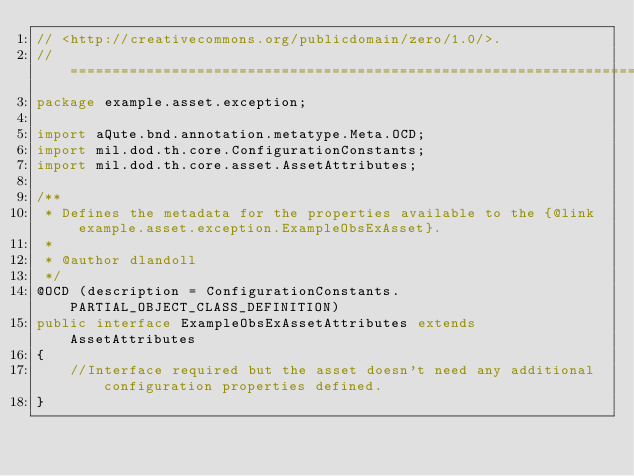<code> <loc_0><loc_0><loc_500><loc_500><_Java_>// <http://creativecommons.org/publicdomain/zero/1.0/>.
//==============================================================================
package example.asset.exception;

import aQute.bnd.annotation.metatype.Meta.OCD;
import mil.dod.th.core.ConfigurationConstants;
import mil.dod.th.core.asset.AssetAttributes;

/**
 * Defines the metadata for the properties available to the {@link example.asset.exception.ExampleObsExAsset}.
 * 
 * @author dlandoll
 */
@OCD (description = ConfigurationConstants.PARTIAL_OBJECT_CLASS_DEFINITION)
public interface ExampleObsExAssetAttributes extends AssetAttributes
{
    //Interface required but the asset doesn't need any additional configuration properties defined.
}
</code> 